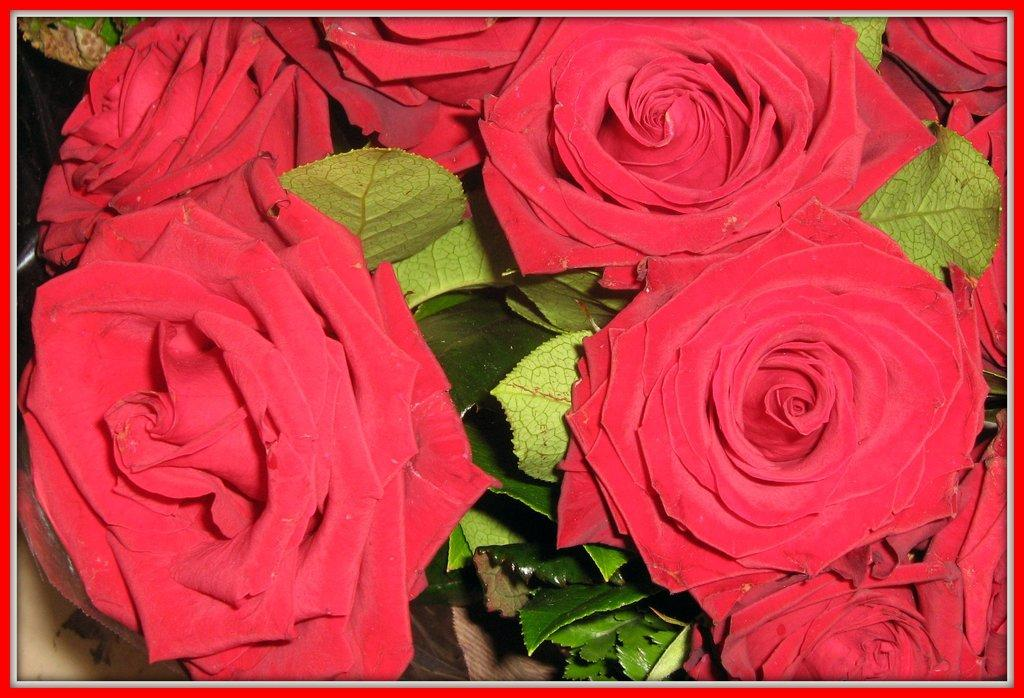What type of plant life can be seen in the image? There are flowers and leaves in the image. Can you describe the appearance of the flowers? Unfortunately, the specific appearance of the flowers cannot be determined from the provided facts. Are there any other elements present in the image besides the flowers and leaves? No additional elements are mentioned in the provided facts. What type of advertisement can be seen on the crate in the image? There is no crate or advertisement present in the image; it only features flowers and leaves. What thought is the person having while looking at the flowers in the image? There is no person present in the image, so their thoughts cannot be determined. 